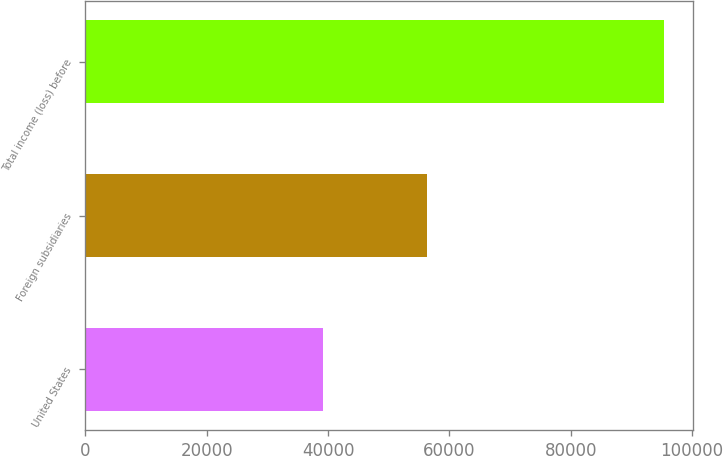Convert chart. <chart><loc_0><loc_0><loc_500><loc_500><bar_chart><fcel>United States<fcel>Foreign subsidiaries<fcel>Total income (loss) before<nl><fcel>39175<fcel>56251<fcel>95426<nl></chart> 